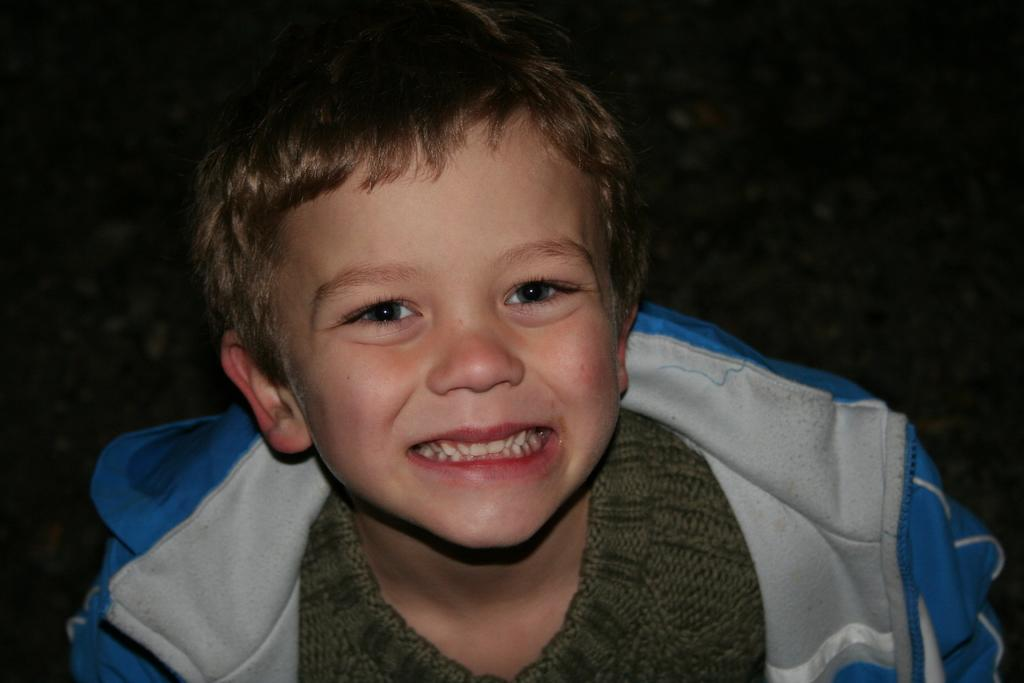Who is the main subject in the image? There is a boy in the image. What is the boy wearing? The boy is wearing a green T-shirt and a blue jacket. What is the boy's facial expression in the image? The boy is smiling. What is the color of the background in the image? The background of the image is black. Can you describe the lighting conditions in the image? The image might have been taken in a dark environment, as indicated by the black background. What type of paper is the boy holding in the image? There is no paper visible in the image; the boy is not holding any paper. What drink is the boy consuming in the image? There is no drink present in the image; the boy is not consuming any drink. 